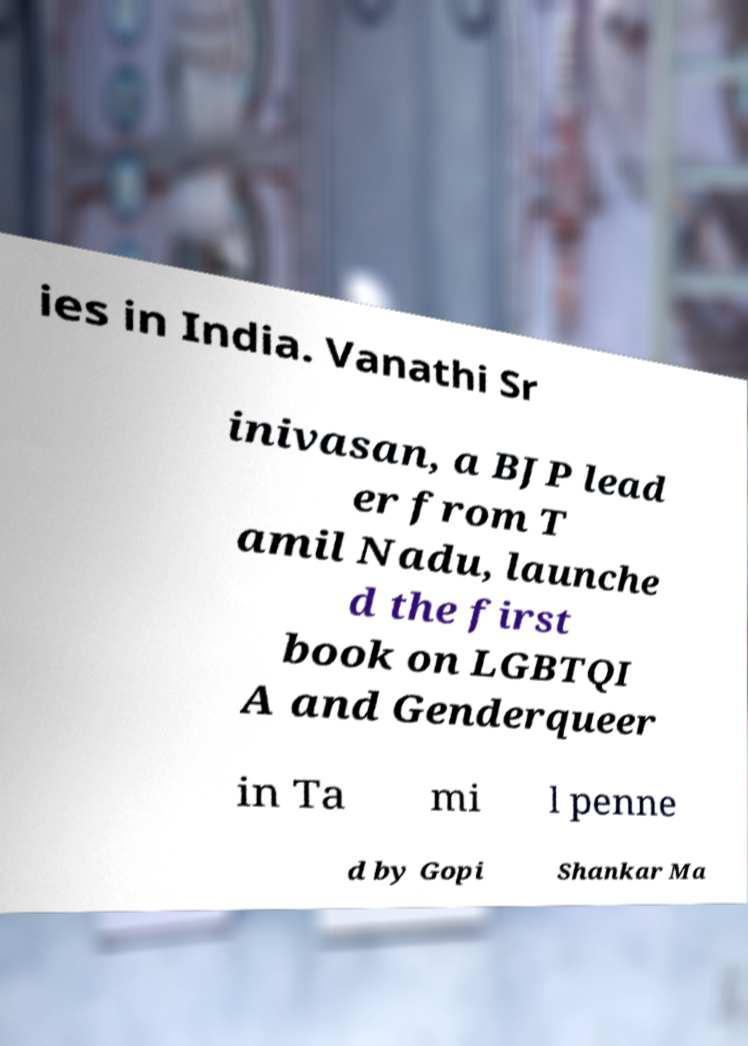What messages or text are displayed in this image? I need them in a readable, typed format. ies in India. Vanathi Sr inivasan, a BJP lead er from T amil Nadu, launche d the first book on LGBTQI A and Genderqueer in Ta mi l penne d by Gopi Shankar Ma 